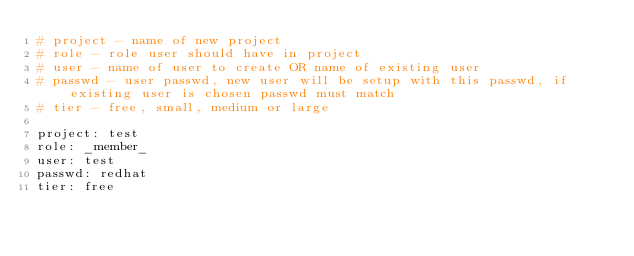Convert code to text. <code><loc_0><loc_0><loc_500><loc_500><_YAML_># project - name of new project
# role - role user should have in project
# user - name of user to create OR name of existing user
# passwd - user passwd, new user will be setup with this passwd, if existing user is chosen passwd must match
# tier - free, small, medium or large

project: test
role: _member_
user: test
passwd: redhat
tier: free
</code> 